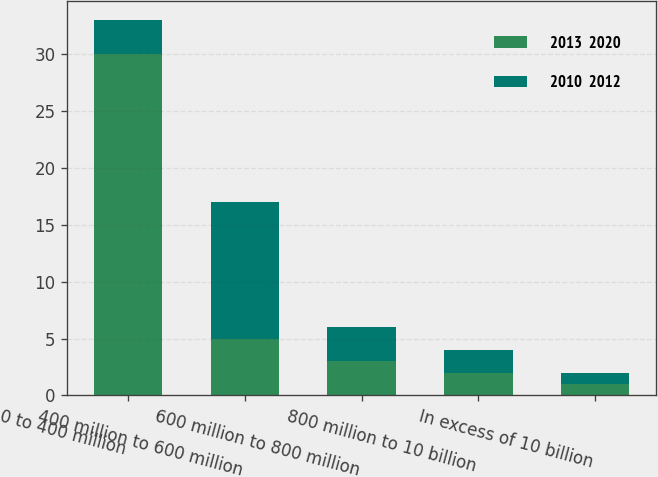Convert chart to OTSL. <chart><loc_0><loc_0><loc_500><loc_500><stacked_bar_chart><ecel><fcel>0 to 400 million<fcel>400 million to 600 million<fcel>600 million to 800 million<fcel>800 million to 10 billion<fcel>In excess of 10 billion<nl><fcel>2013  2020<fcel>30<fcel>5<fcel>3<fcel>2<fcel>1<nl><fcel>2010  2012<fcel>3<fcel>12<fcel>3<fcel>2<fcel>1<nl></chart> 